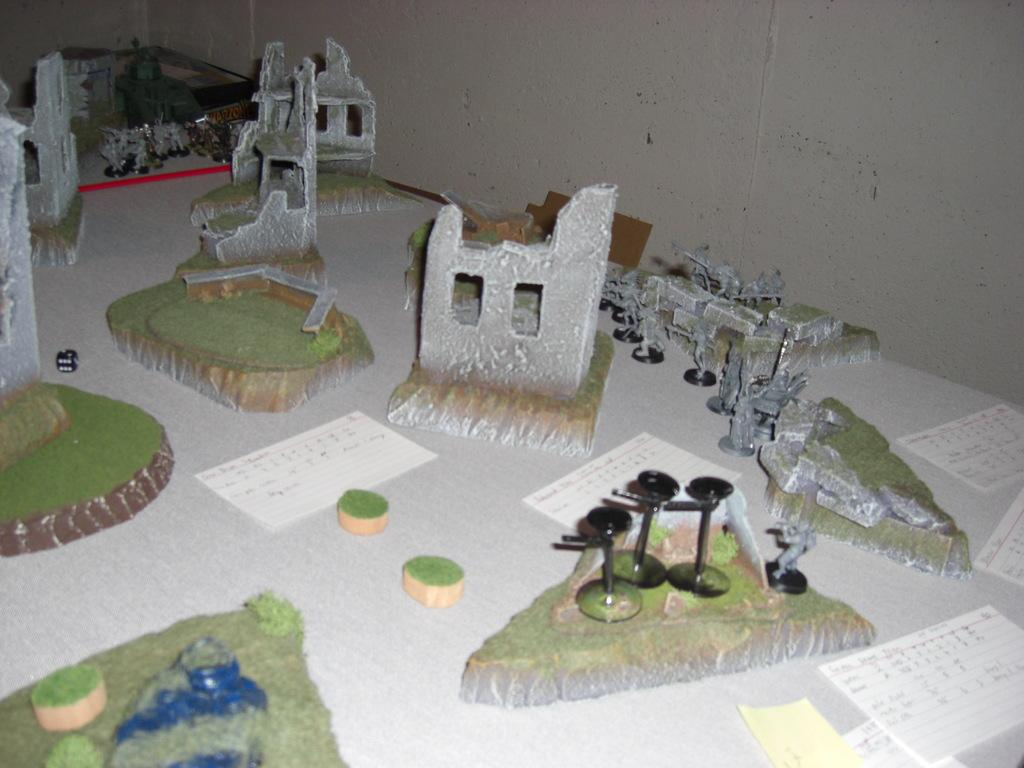What type of scene is depicted in the image? The image is of a miniature. What structures are present in the miniature scene? There are artificial buildings in the image. What type of pathways are present in the miniature scene? There are roads in the image. What type of vegetation is present in the miniature scene? There is grass in the image. What type of barrier is present at the back of the miniature scene? There is a wall at the back of the image. What type of canvas is used to create the miniature scene in the image? The image does not depict a canvas; it is a photograph of a miniature scene. How does the grass in the image exhibit growth? The grass in the image is artificial and does not exhibit growth, as it is part of a miniature scene. 